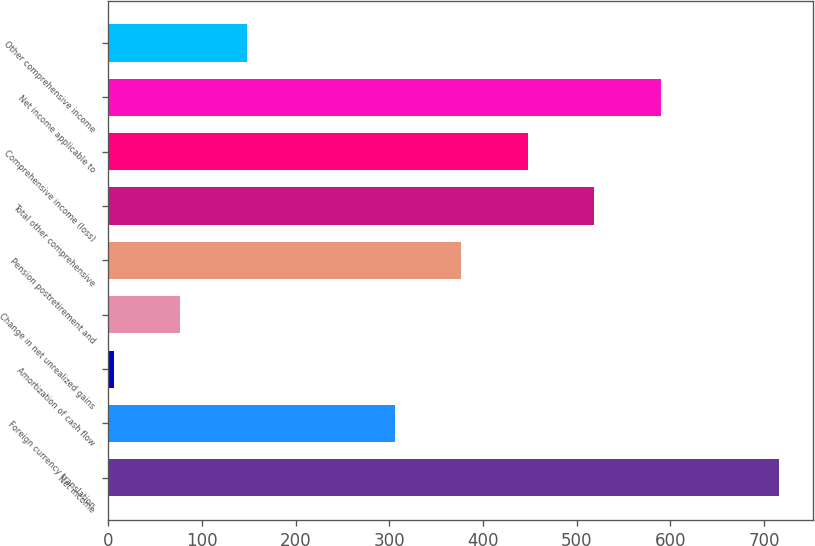Convert chart. <chart><loc_0><loc_0><loc_500><loc_500><bar_chart><fcel>Net income<fcel>Foreign currency translation<fcel>Amortization of cash flow<fcel>Change in net unrealized gains<fcel>Pension postretirement and<fcel>Total other comprehensive<fcel>Comprehensive income (loss)<fcel>Net income applicable to<fcel>Other comprehensive income<nl><fcel>716<fcel>306<fcel>6<fcel>77<fcel>377<fcel>519<fcel>448<fcel>590<fcel>148<nl></chart> 